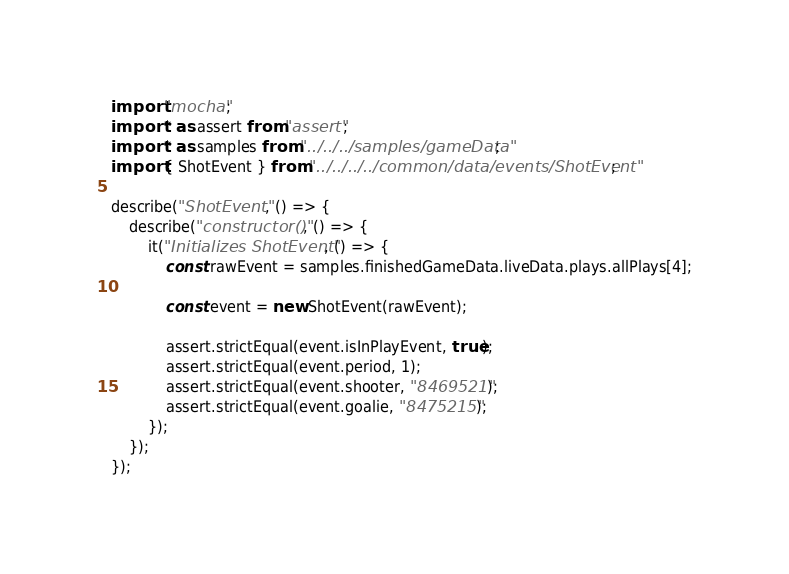<code> <loc_0><loc_0><loc_500><loc_500><_TypeScript_>import "mocha";
import * as assert from "assert";
import * as samples from "../../../samples/gameData";
import { ShotEvent } from "../../../../common/data/events/ShotEvent";

describe("ShotEvent", () => {
    describe("constructor()", () => {
        it("Initializes ShotEvent", () => {
            const rawEvent = samples.finishedGameData.liveData.plays.allPlays[4];

            const event = new ShotEvent(rawEvent);

            assert.strictEqual(event.isInPlayEvent, true);
            assert.strictEqual(event.period, 1);
            assert.strictEqual(event.shooter, "8469521");
            assert.strictEqual(event.goalie, "8475215");
        });
    });
});
</code> 